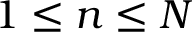Convert formula to latex. <formula><loc_0><loc_0><loc_500><loc_500>1 \leq n \leq N</formula> 